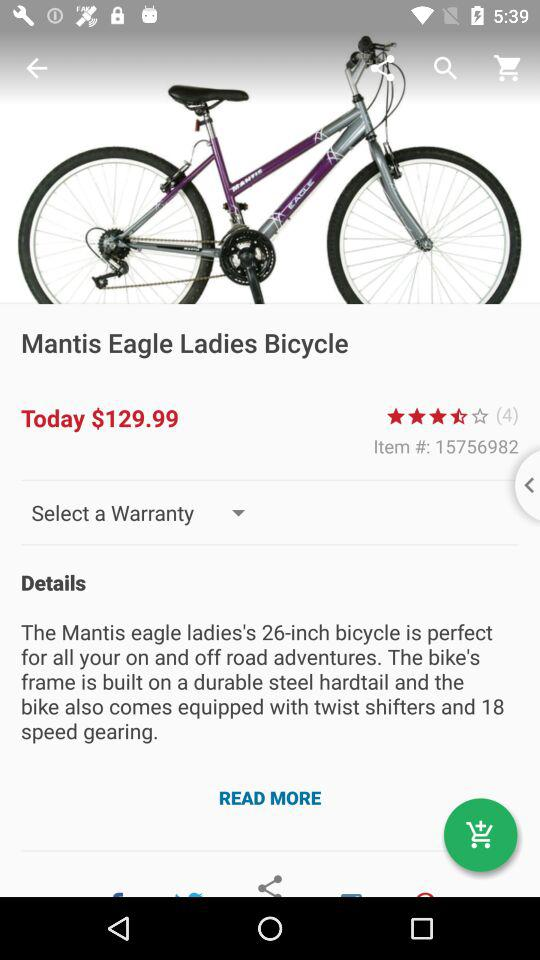What is the name of the bicycle? The name of the bicycle is "Mantis eagle ladies bicycle". 